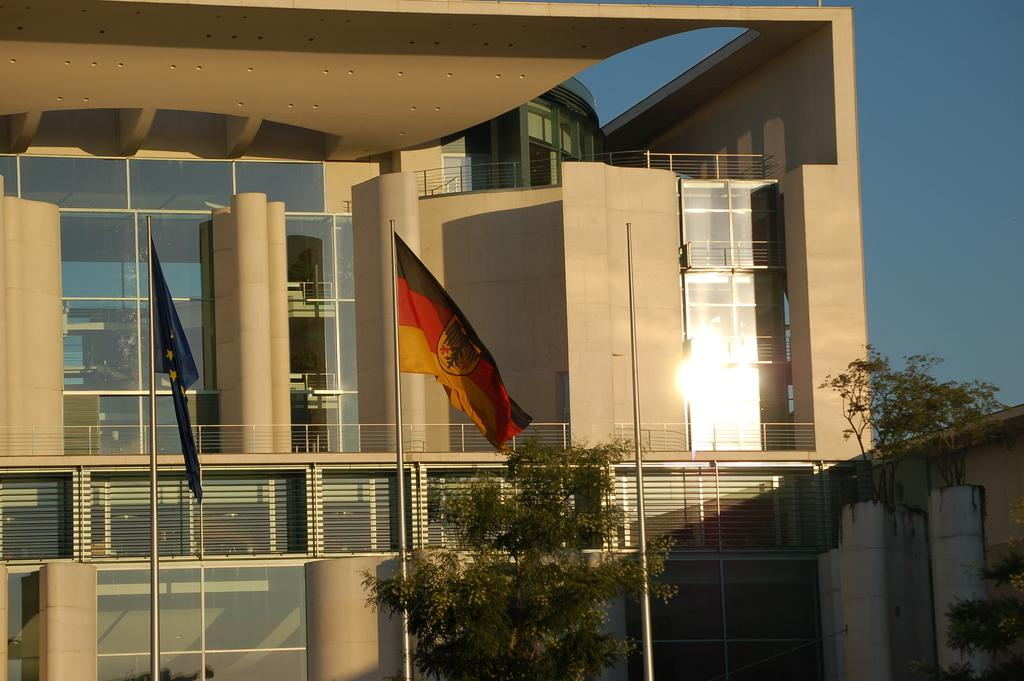What type of structure is present in the image? There is a building in the image. What specific features can be observed on the building? The building has glass elements and pillars. Are there any additional objects near the building? Yes, there are flags on poles near the building. What can be seen in the background of the image? The sky is visible in the background of the image. What type of vegetation is present in the image? There are trees in the image. What type of pear can be seen hanging from the tree in the image? There is no pear present in the image; only trees are visible. What effect does the building have on the surrounding environment in the image? The provided facts do not mention any specific effects the building has on the surrounding environment. 